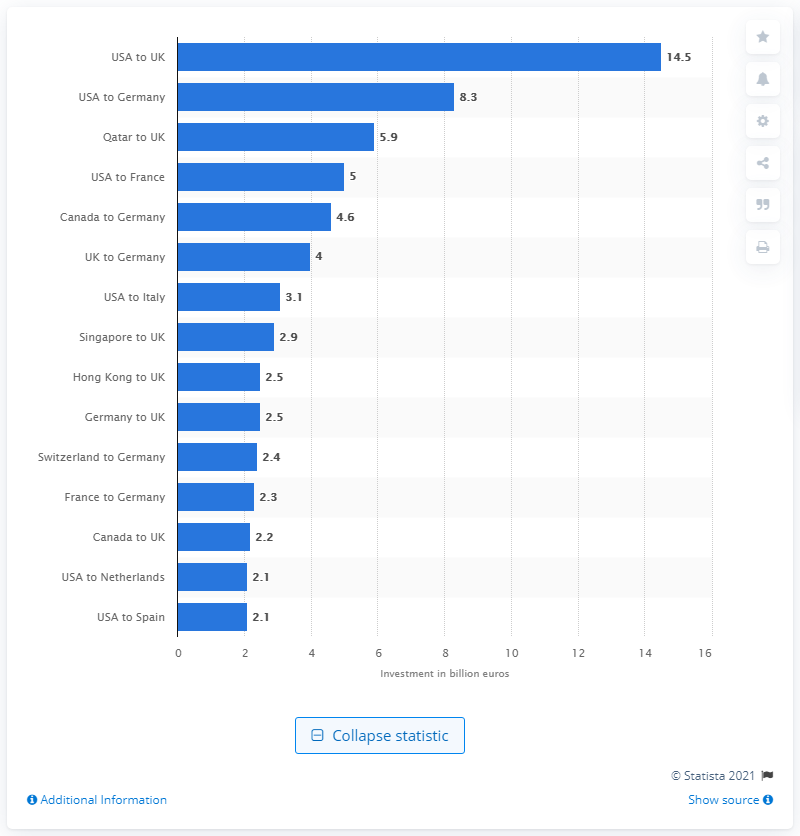Give some essential details in this illustration. In the first quarter of 2016, a total of 14.5 million dollars was invested in the United Kingdom market. 